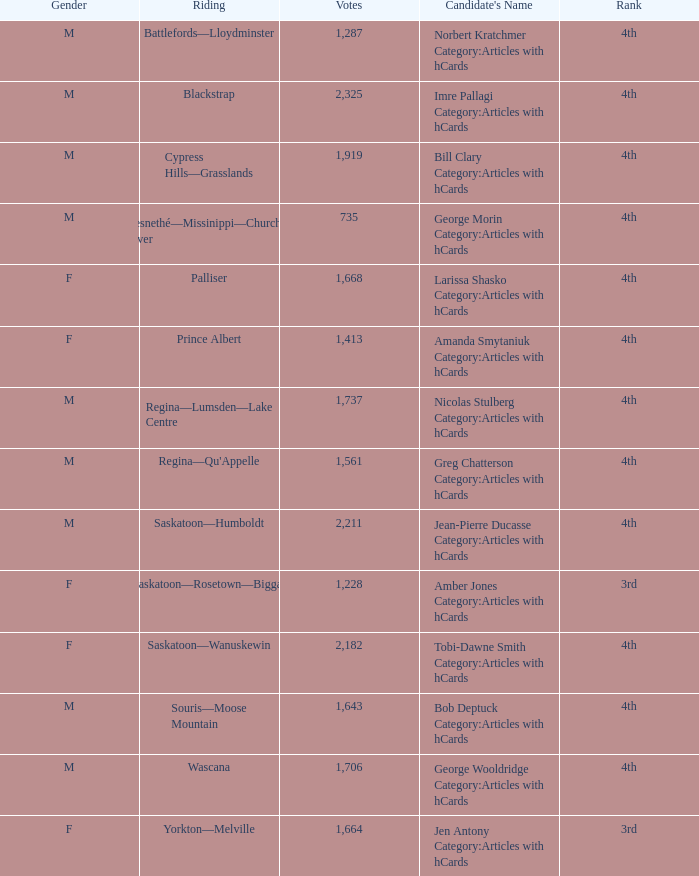What is the rank of the candidate with more than 2,211 votes? 4th. 